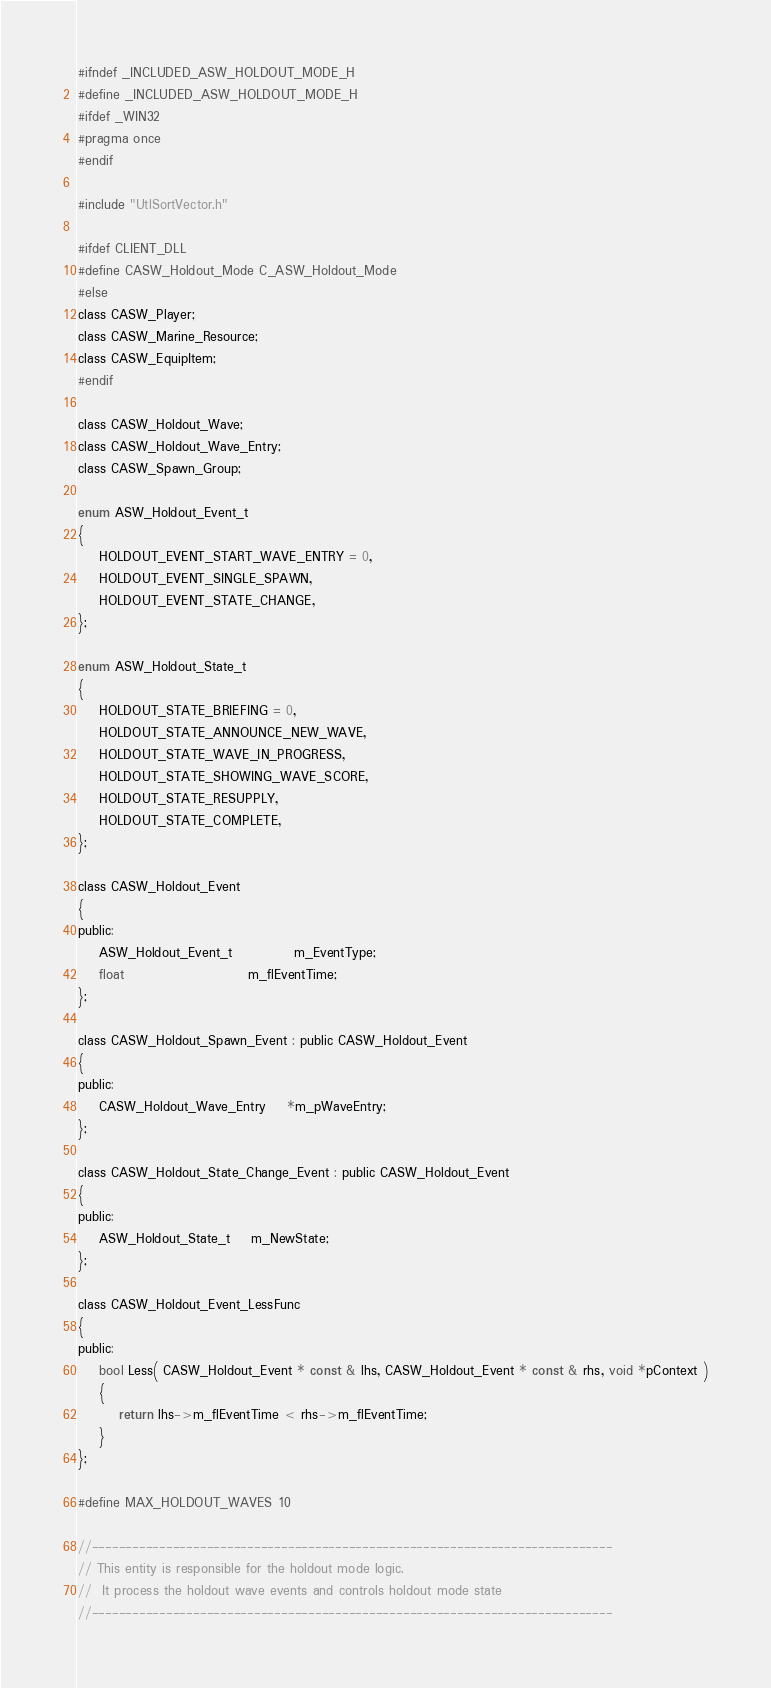<code> <loc_0><loc_0><loc_500><loc_500><_C_>#ifndef _INCLUDED_ASW_HOLDOUT_MODE_H
#define _INCLUDED_ASW_HOLDOUT_MODE_H
#ifdef _WIN32
#pragma once
#endif

#include "UtlSortVector.h"

#ifdef CLIENT_DLL
#define CASW_Holdout_Mode C_ASW_Holdout_Mode
#else
class CASW_Player;
class CASW_Marine_Resource;
class CASW_EquipItem;
#endif

class CASW_Holdout_Wave;
class CASW_Holdout_Wave_Entry;
class CASW_Spawn_Group;

enum ASW_Holdout_Event_t
{
	HOLDOUT_EVENT_START_WAVE_ENTRY = 0,
	HOLDOUT_EVENT_SINGLE_SPAWN,
	HOLDOUT_EVENT_STATE_CHANGE,
};

enum ASW_Holdout_State_t
{
	HOLDOUT_STATE_BRIEFING = 0,
	HOLDOUT_STATE_ANNOUNCE_NEW_WAVE,
	HOLDOUT_STATE_WAVE_IN_PROGRESS,
	HOLDOUT_STATE_SHOWING_WAVE_SCORE,
	HOLDOUT_STATE_RESUPPLY,
	HOLDOUT_STATE_COMPLETE,
};

class CASW_Holdout_Event
{
public:
	ASW_Holdout_Event_t			m_EventType;
	float						m_flEventTime;
};

class CASW_Holdout_Spawn_Event : public CASW_Holdout_Event
{
public:
	CASW_Holdout_Wave_Entry 	*m_pWaveEntry;
};

class CASW_Holdout_State_Change_Event : public CASW_Holdout_Event
{
public:
	ASW_Holdout_State_t 	m_NewState;
};

class CASW_Holdout_Event_LessFunc
{
public:
	bool Less( CASW_Holdout_Event * const & lhs, CASW_Holdout_Event * const & rhs, void *pContext )
	{
		return lhs->m_flEventTime < rhs->m_flEventTime;
	}
};

#define MAX_HOLDOUT_WAVES 10

//-----------------------------------------------------------------------------
// This entity is responsible for the holdout mode logic.
//  It process the holdout wave events and controls holdout mode state
//-----------------------------------------------------------------------------</code> 